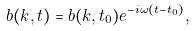Convert formula to latex. <formula><loc_0><loc_0><loc_500><loc_500>b ( k , t ) = b ( k , t _ { 0 } ) e ^ { - i \omega ( t - t _ { 0 } ) } ,</formula> 